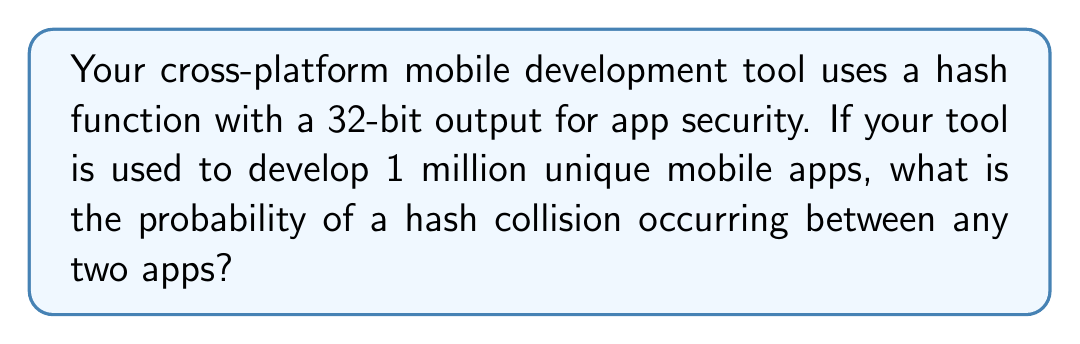Could you help me with this problem? To solve this problem, we'll use the birthday paradox principle, which is applicable to hash collision probability.

Step 1: Determine the number of possible hash values.
For a 32-bit hash, there are $2^{32}$ possible hash values.

Step 2: Calculate the probability of no collision.
The probability of no collision for n apps is:

$$ P(\text{no collision}) = \frac{2^{32}!}{(2^{32}-n)! \cdot 2^{32n}} $$

Where n = 1,000,000 (1 million apps)

Step 3: Simplify the calculation using the approximation:

$$ P(\text{no collision}) \approx e^{-\frac{n(n-1)}{2m}} $$

Where m = $2^{32}$ (number of possible hash values)

Step 4: Plug in the values:

$$ P(\text{no collision}) \approx e^{-\frac{1,000,000(999,999)}{2 \cdot 2^{32}}} $$

Step 5: Calculate:

$$ P(\text{no collision}) \approx e^{-116.415} \approx 2.31 \times 10^{-51} $$

Step 6: The probability of a collision is the complement of no collision:

$$ P(\text{collision}) = 1 - P(\text{no collision}) $$
$$ P(\text{collision}) = 1 - 2.31 \times 10^{-51} \approx 0.999999999999999999999999999999999999999999999999977 $$
Answer: $\approx 0.9999999999999999$ (or virtually 1) 